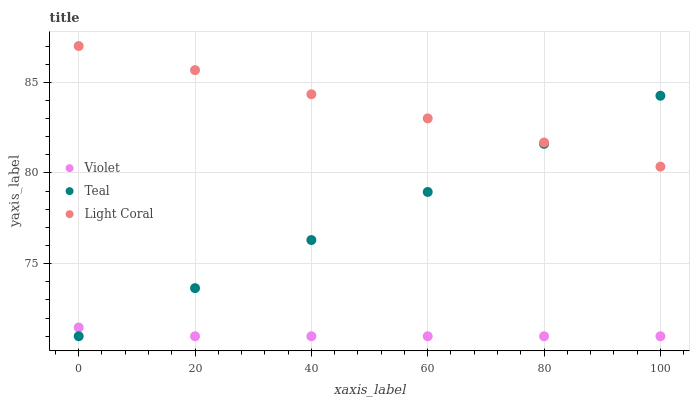Does Violet have the minimum area under the curve?
Answer yes or no. Yes. Does Light Coral have the maximum area under the curve?
Answer yes or no. Yes. Does Teal have the minimum area under the curve?
Answer yes or no. No. Does Teal have the maximum area under the curve?
Answer yes or no. No. Is Light Coral the smoothest?
Answer yes or no. Yes. Is Violet the roughest?
Answer yes or no. Yes. Is Teal the smoothest?
Answer yes or no. No. Is Teal the roughest?
Answer yes or no. No. Does Teal have the lowest value?
Answer yes or no. Yes. Does Light Coral have the highest value?
Answer yes or no. Yes. Does Teal have the highest value?
Answer yes or no. No. Is Violet less than Light Coral?
Answer yes or no. Yes. Is Light Coral greater than Violet?
Answer yes or no. Yes. Does Teal intersect Violet?
Answer yes or no. Yes. Is Teal less than Violet?
Answer yes or no. No. Is Teal greater than Violet?
Answer yes or no. No. Does Violet intersect Light Coral?
Answer yes or no. No. 